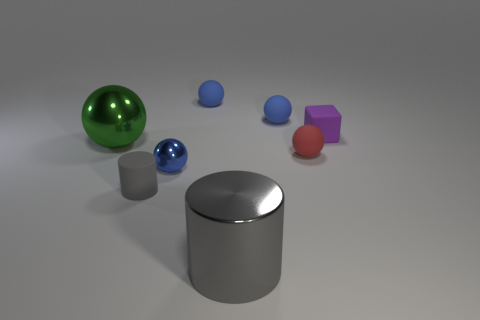Subtract all small blue rubber balls. How many balls are left? 3 Subtract all cyan cylinders. How many blue balls are left? 3 Add 1 rubber blocks. How many objects exist? 9 Subtract all red spheres. How many spheres are left? 4 Subtract all green balls. Subtract all yellow cylinders. How many balls are left? 4 Subtract 0 cyan spheres. How many objects are left? 8 Subtract all blocks. How many objects are left? 7 Subtract all tiny cubes. Subtract all tiny objects. How many objects are left? 1 Add 5 red matte spheres. How many red matte spheres are left? 6 Add 7 small gray things. How many small gray things exist? 8 